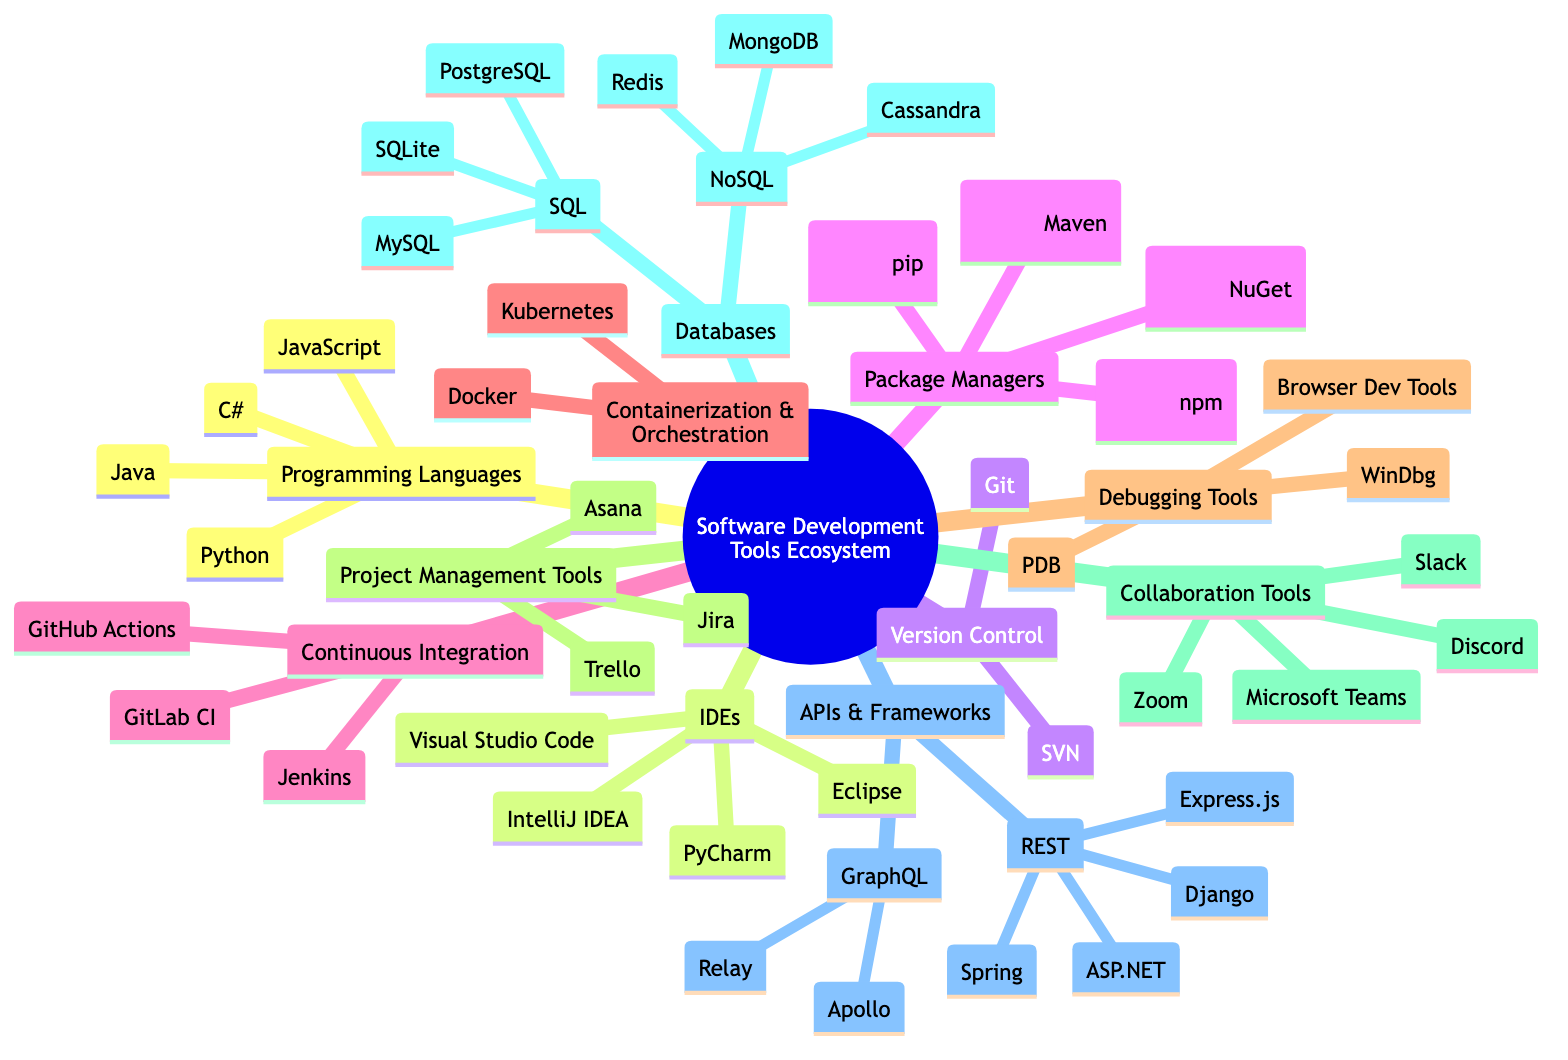What are the programming languages listed in the ecosystem? The diagram shows four programming languages under the "Programming Languages" category: JavaScript, Python, Java, and C#.
Answer: JavaScript, Python, Java, C# How many IDEs are included in the diagram? There are four IDEs mentioned under the "IDEs" category: Visual Studio Code, PyCharm, IntelliJ IDEA, and Eclipse.
Answer: 4 Which package manager is associated with Python? In the "Package Managers" section, pip is specified as the package manager associated with Python.
Answer: pip What continuous integration tools are listed in the ecosystem? The "Continuous Integration" category includes Jenkins, GitHub Actions, and GitLab CI.
Answer: Jenkins, GitHub Actions, GitLab CI Which debugging tool is commonly used with JavaScript? Under the "Debugging Tools", Browser Dev Tools is noted as commonly used with JavaScript.
Answer: Browser Dev Tools How many types of databases are represented in the diagram? There are two main types of databases indicated: SQL and NoSQL, categorizing the database types under "Databases".
Answer: 2 What associated language uses the NuGet package manager? The "Package Managers" section shows that NuGet is associated with the C# programming language.
Answer: C# What is the relationship between REST and the common libraries listed? REST is linked to several common libraries such as Express.js, Django, Spring, and ASP.NET, indicating that these libraries are used for building RESTful APIs.
Answer: Common libraries: Express.js, Django, Spring, ASP.NET Which collaboration tools are mentioned in the diagram? The "Collaboration Tools" section lists Slack, Microsoft Teams, Discord, and Zoom as the tools available for collaboration.
Answer: Slack, Microsoft Teams, Discord, Zoom Which package manager is related to JavaScript? The diagram shows that npm is the package manager associated with JavaScript in the "Package Managers" section.
Answer: npm 